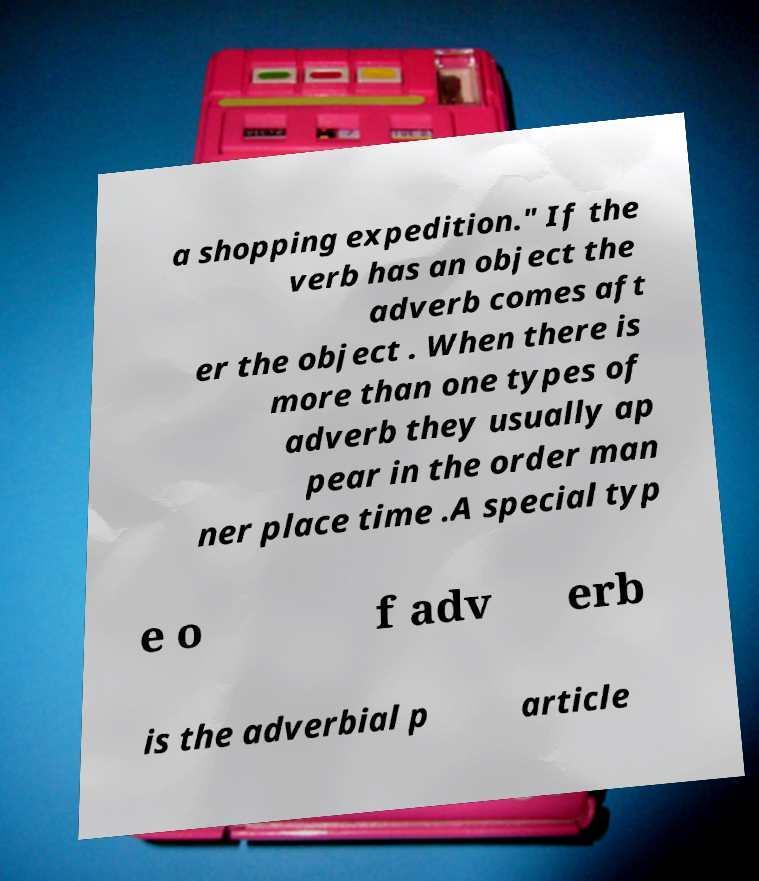Could you assist in decoding the text presented in this image and type it out clearly? a shopping expedition." If the verb has an object the adverb comes aft er the object . When there is more than one types of adverb they usually ap pear in the order man ner place time .A special typ e o f adv erb is the adverbial p article 